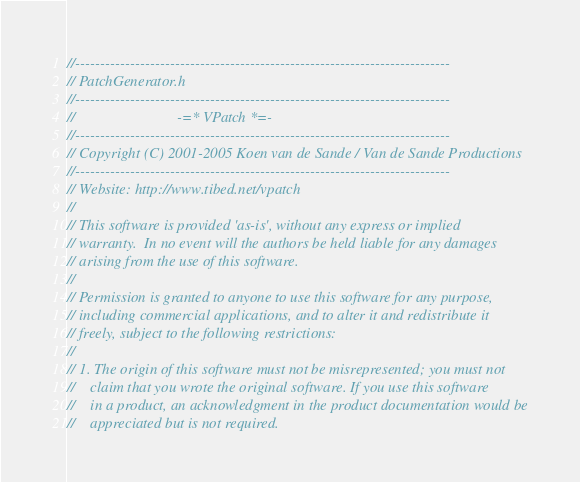<code> <loc_0><loc_0><loc_500><loc_500><_C_>//---------------------------------------------------------------------------
// PatchGenerator.h
//---------------------------------------------------------------------------
//                           -=* VPatch *=-
//---------------------------------------------------------------------------
// Copyright (C) 2001-2005 Koen van de Sande / Van de Sande Productions
//---------------------------------------------------------------------------
// Website: http://www.tibed.net/vpatch
//
// This software is provided 'as-is', without any express or implied
// warranty.  In no event will the authors be held liable for any damages
// arising from the use of this software.
//
// Permission is granted to anyone to use this software for any purpose,
// including commercial applications, and to alter it and redistribute it
// freely, subject to the following restrictions:
//
// 1. The origin of this software must not be misrepresented; you must not
//    claim that you wrote the original software. If you use this software
//    in a product, an acknowledgment in the product documentation would be
//    appreciated but is not required.</code> 